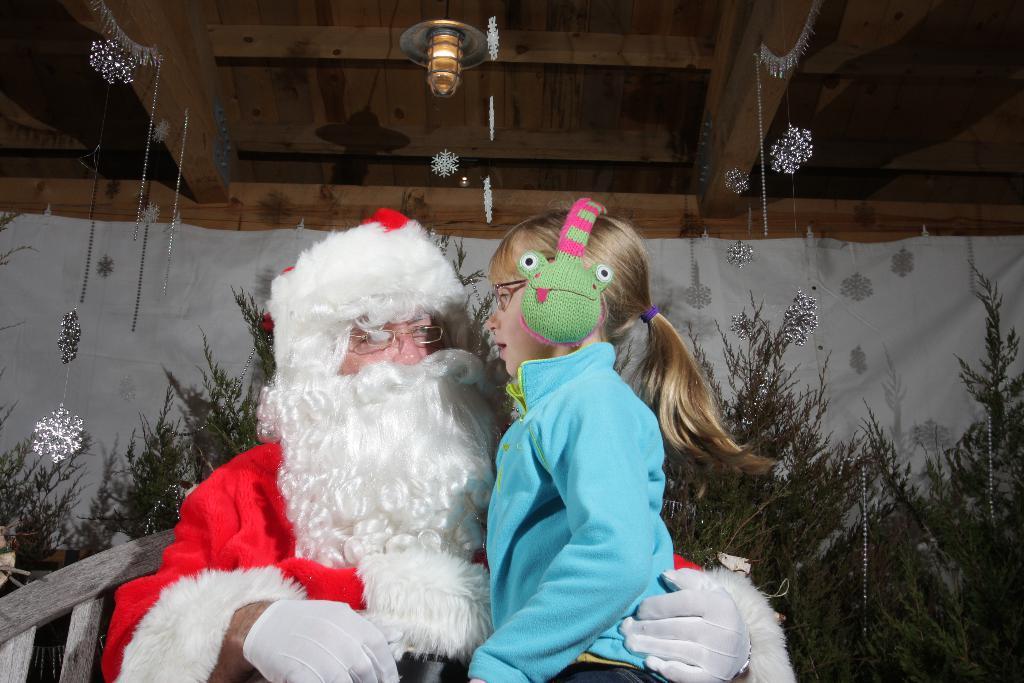Please provide a concise description of this image. In the center of the image we can see a santa claus and there is a girl wearing a headset. In the background there are trees, curtain, decors and lights. 